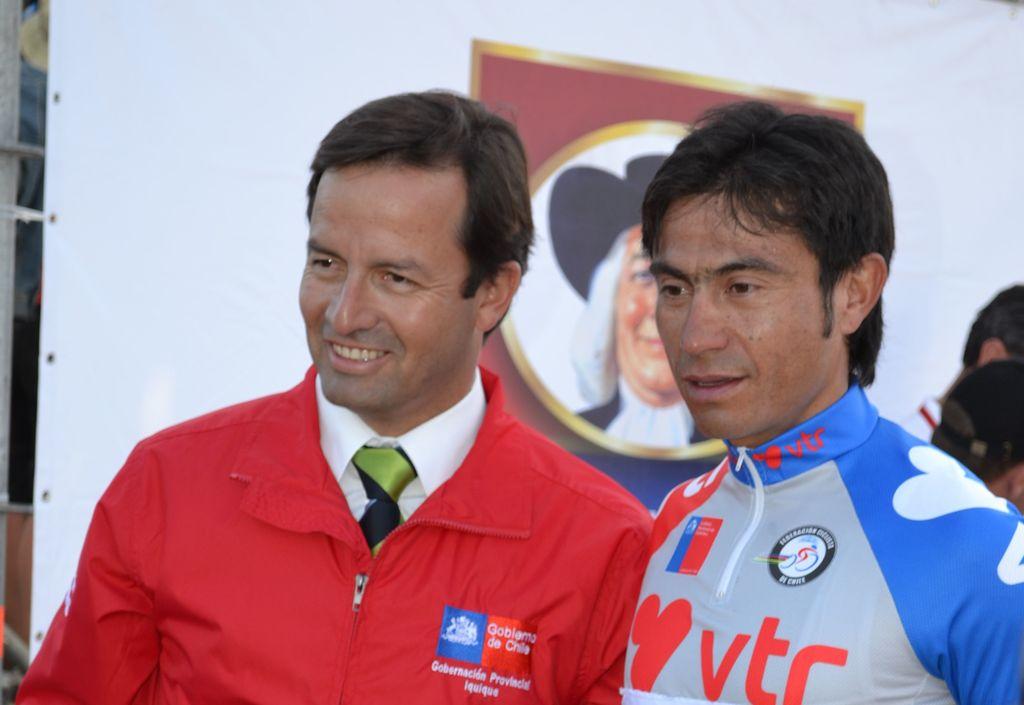Who is the driver's sponsor?
Provide a short and direct response. Vtr. What three letters are in red on the man on the right's neck?
Offer a terse response. Vtr. 